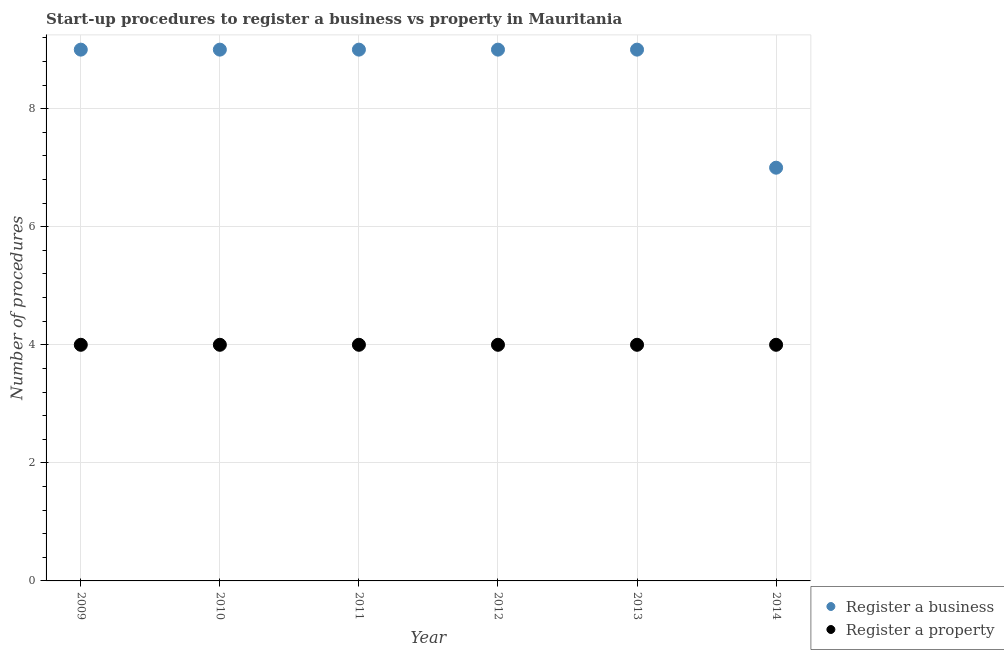What is the number of procedures to register a property in 2014?
Ensure brevity in your answer.  4. Across all years, what is the maximum number of procedures to register a property?
Give a very brief answer. 4. Across all years, what is the minimum number of procedures to register a property?
Make the answer very short. 4. In which year was the number of procedures to register a property maximum?
Make the answer very short. 2009. In which year was the number of procedures to register a property minimum?
Your answer should be compact. 2009. What is the total number of procedures to register a business in the graph?
Make the answer very short. 52. What is the difference between the number of procedures to register a business in 2011 and that in 2014?
Provide a short and direct response. 2. What is the difference between the number of procedures to register a property in 2014 and the number of procedures to register a business in 2009?
Your answer should be very brief. -5. In the year 2011, what is the difference between the number of procedures to register a property and number of procedures to register a business?
Make the answer very short. -5. Is the number of procedures to register a business in 2010 less than that in 2014?
Provide a short and direct response. No. Is the difference between the number of procedures to register a business in 2010 and 2014 greater than the difference between the number of procedures to register a property in 2010 and 2014?
Offer a very short reply. Yes. What is the difference between the highest and the lowest number of procedures to register a business?
Your answer should be compact. 2. In how many years, is the number of procedures to register a business greater than the average number of procedures to register a business taken over all years?
Offer a very short reply. 5. Is the sum of the number of procedures to register a property in 2011 and 2013 greater than the maximum number of procedures to register a business across all years?
Your response must be concise. No. Does the number of procedures to register a property monotonically increase over the years?
Your answer should be very brief. No. Is the number of procedures to register a business strictly greater than the number of procedures to register a property over the years?
Provide a short and direct response. Yes. What is the difference between two consecutive major ticks on the Y-axis?
Ensure brevity in your answer.  2. Are the values on the major ticks of Y-axis written in scientific E-notation?
Your answer should be very brief. No. How many legend labels are there?
Offer a very short reply. 2. How are the legend labels stacked?
Your answer should be compact. Vertical. What is the title of the graph?
Your answer should be very brief. Start-up procedures to register a business vs property in Mauritania. Does "Diesel" appear as one of the legend labels in the graph?
Your answer should be compact. No. What is the label or title of the X-axis?
Keep it short and to the point. Year. What is the label or title of the Y-axis?
Offer a very short reply. Number of procedures. What is the Number of procedures of Register a property in 2011?
Provide a succinct answer. 4. What is the Number of procedures of Register a business in 2012?
Offer a terse response. 9. What is the Number of procedures in Register a property in 2012?
Your answer should be very brief. 4. Across all years, what is the maximum Number of procedures in Register a property?
Your answer should be very brief. 4. Across all years, what is the minimum Number of procedures of Register a business?
Make the answer very short. 7. Across all years, what is the minimum Number of procedures of Register a property?
Your answer should be very brief. 4. What is the total Number of procedures of Register a business in the graph?
Offer a very short reply. 52. What is the difference between the Number of procedures of Register a business in 2009 and that in 2010?
Ensure brevity in your answer.  0. What is the difference between the Number of procedures of Register a business in 2009 and that in 2011?
Provide a short and direct response. 0. What is the difference between the Number of procedures in Register a property in 2009 and that in 2011?
Provide a succinct answer. 0. What is the difference between the Number of procedures in Register a business in 2009 and that in 2012?
Your response must be concise. 0. What is the difference between the Number of procedures in Register a property in 2009 and that in 2012?
Offer a terse response. 0. What is the difference between the Number of procedures in Register a business in 2009 and that in 2013?
Offer a very short reply. 0. What is the difference between the Number of procedures in Register a property in 2009 and that in 2014?
Provide a short and direct response. 0. What is the difference between the Number of procedures of Register a business in 2010 and that in 2013?
Your response must be concise. 0. What is the difference between the Number of procedures in Register a property in 2010 and that in 2013?
Make the answer very short. 0. What is the difference between the Number of procedures of Register a business in 2010 and that in 2014?
Give a very brief answer. 2. What is the difference between the Number of procedures in Register a property in 2010 and that in 2014?
Make the answer very short. 0. What is the difference between the Number of procedures of Register a property in 2011 and that in 2012?
Give a very brief answer. 0. What is the difference between the Number of procedures in Register a business in 2011 and that in 2013?
Your answer should be compact. 0. What is the difference between the Number of procedures of Register a property in 2011 and that in 2013?
Provide a short and direct response. 0. What is the difference between the Number of procedures in Register a business in 2011 and that in 2014?
Your answer should be compact. 2. What is the difference between the Number of procedures of Register a business in 2013 and that in 2014?
Offer a terse response. 2. What is the difference between the Number of procedures in Register a property in 2013 and that in 2014?
Provide a short and direct response. 0. What is the difference between the Number of procedures in Register a business in 2009 and the Number of procedures in Register a property in 2011?
Offer a very short reply. 5. What is the difference between the Number of procedures in Register a business in 2010 and the Number of procedures in Register a property in 2014?
Give a very brief answer. 5. What is the difference between the Number of procedures of Register a business in 2012 and the Number of procedures of Register a property in 2013?
Your answer should be very brief. 5. What is the difference between the Number of procedures of Register a business in 2012 and the Number of procedures of Register a property in 2014?
Keep it short and to the point. 5. What is the average Number of procedures of Register a business per year?
Offer a very short reply. 8.67. What is the average Number of procedures of Register a property per year?
Your response must be concise. 4. In the year 2009, what is the difference between the Number of procedures in Register a business and Number of procedures in Register a property?
Provide a succinct answer. 5. In the year 2011, what is the difference between the Number of procedures in Register a business and Number of procedures in Register a property?
Offer a very short reply. 5. In the year 2012, what is the difference between the Number of procedures of Register a business and Number of procedures of Register a property?
Offer a terse response. 5. What is the ratio of the Number of procedures of Register a business in 2009 to that in 2010?
Your answer should be compact. 1. What is the ratio of the Number of procedures in Register a property in 2009 to that in 2010?
Your answer should be compact. 1. What is the ratio of the Number of procedures in Register a property in 2009 to that in 2011?
Make the answer very short. 1. What is the ratio of the Number of procedures in Register a property in 2009 to that in 2012?
Your answer should be very brief. 1. What is the ratio of the Number of procedures in Register a business in 2009 to that in 2013?
Keep it short and to the point. 1. What is the ratio of the Number of procedures of Register a property in 2010 to that in 2011?
Ensure brevity in your answer.  1. What is the ratio of the Number of procedures of Register a business in 2010 to that in 2012?
Offer a terse response. 1. What is the ratio of the Number of procedures in Register a property in 2010 to that in 2012?
Provide a succinct answer. 1. What is the ratio of the Number of procedures of Register a business in 2010 to that in 2013?
Provide a short and direct response. 1. What is the ratio of the Number of procedures of Register a property in 2010 to that in 2014?
Provide a short and direct response. 1. What is the ratio of the Number of procedures of Register a business in 2011 to that in 2012?
Keep it short and to the point. 1. What is the ratio of the Number of procedures in Register a property in 2011 to that in 2012?
Offer a terse response. 1. What is the ratio of the Number of procedures in Register a business in 2011 to that in 2013?
Offer a terse response. 1. What is the ratio of the Number of procedures of Register a property in 2011 to that in 2014?
Your response must be concise. 1. What is the ratio of the Number of procedures of Register a business in 2012 to that in 2013?
Your answer should be compact. 1. What is the ratio of the Number of procedures of Register a property in 2012 to that in 2014?
Keep it short and to the point. 1. What is the ratio of the Number of procedures in Register a business in 2013 to that in 2014?
Your answer should be very brief. 1.29. What is the difference between the highest and the lowest Number of procedures of Register a property?
Your answer should be compact. 0. 